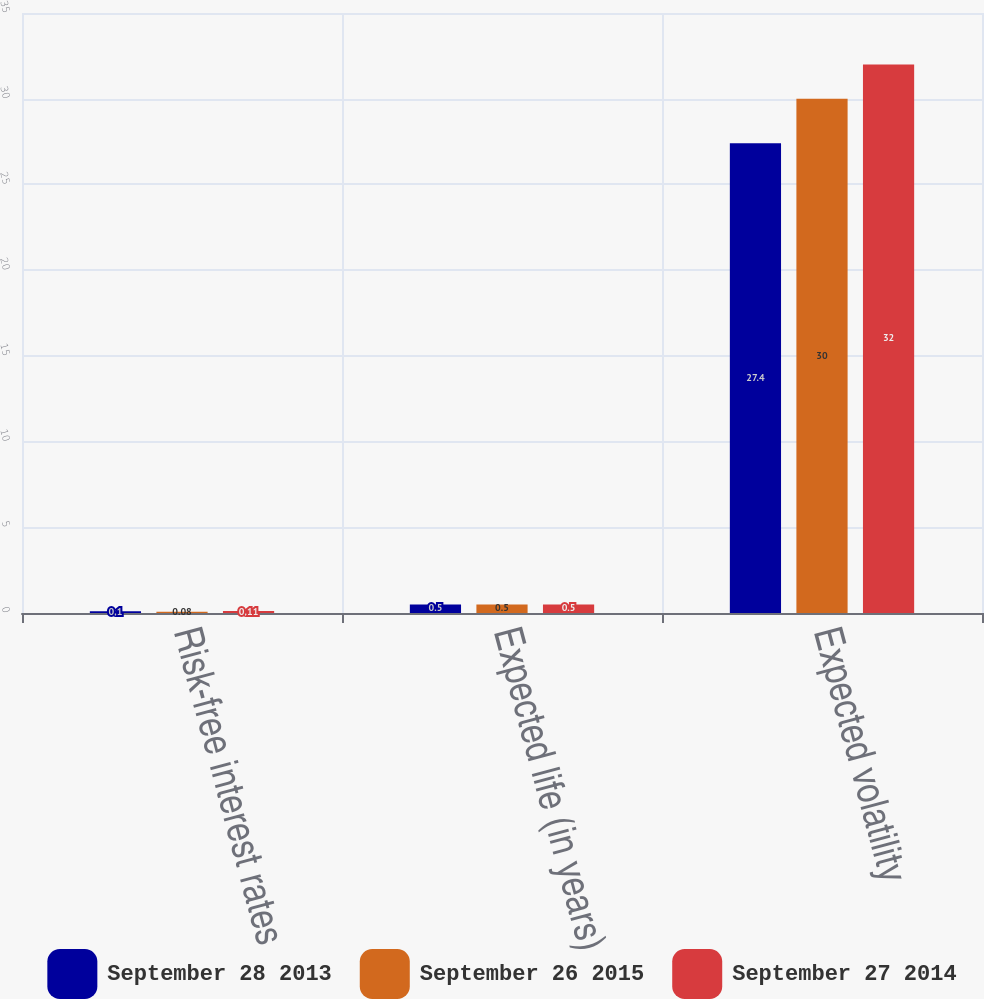Convert chart to OTSL. <chart><loc_0><loc_0><loc_500><loc_500><stacked_bar_chart><ecel><fcel>Risk-free interest rates<fcel>Expected life (in years)<fcel>Expected volatility<nl><fcel>September 28 2013<fcel>0.1<fcel>0.5<fcel>27.4<nl><fcel>September 26 2015<fcel>0.08<fcel>0.5<fcel>30<nl><fcel>September 27 2014<fcel>0.11<fcel>0.5<fcel>32<nl></chart> 